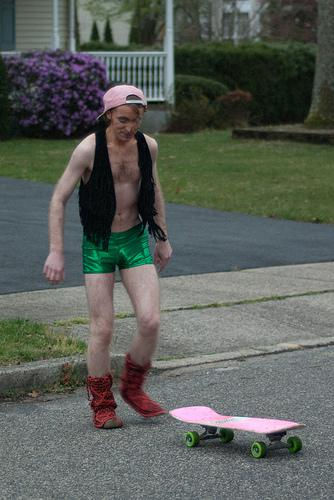Question: how many skateboards are on the ground?
Choices:
A. None.
B. Two.
C. Three.
D. One.
Answer with the letter. Answer: D Question: where are the flowers?
Choices:
A. In the backyard.
B. In front of the porch.
C. On the terrace.
D. In front of the bushes.
Answer with the letter. Answer: B Question: who is wearing a vest?
Choices:
A. The man.
B. The conductor.
C. The congressman.
D. The broker.
Answer with the letter. Answer: A 